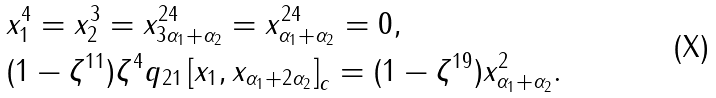<formula> <loc_0><loc_0><loc_500><loc_500>& x _ { 1 } ^ { 4 } = x _ { 2 } ^ { 3 } = x _ { 3 \alpha _ { 1 } + \alpha _ { 2 } } ^ { 2 4 } = x _ { \alpha _ { 1 } + \alpha _ { 2 } } ^ { 2 4 } = 0 , \\ & ( 1 - \zeta ^ { 1 1 } ) \zeta ^ { 4 } q _ { 2 1 } \left [ x _ { 1 } , x _ { \alpha _ { 1 } + 2 \alpha _ { 2 } } \right ] _ { c } = ( 1 - \zeta ^ { 1 9 } ) x _ { \alpha _ { 1 } + \alpha _ { 2 } } ^ { 2 } .</formula> 